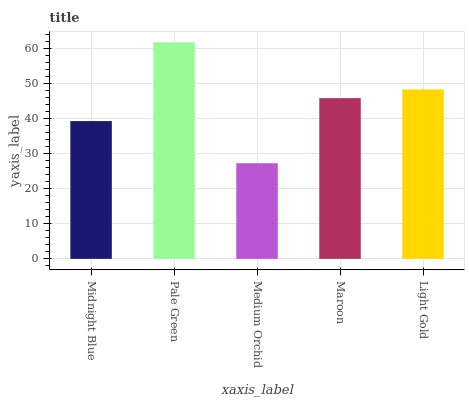Is Medium Orchid the minimum?
Answer yes or no. Yes. Is Pale Green the maximum?
Answer yes or no. Yes. Is Pale Green the minimum?
Answer yes or no. No. Is Medium Orchid the maximum?
Answer yes or no. No. Is Pale Green greater than Medium Orchid?
Answer yes or no. Yes. Is Medium Orchid less than Pale Green?
Answer yes or no. Yes. Is Medium Orchid greater than Pale Green?
Answer yes or no. No. Is Pale Green less than Medium Orchid?
Answer yes or no. No. Is Maroon the high median?
Answer yes or no. Yes. Is Maroon the low median?
Answer yes or no. Yes. Is Midnight Blue the high median?
Answer yes or no. No. Is Medium Orchid the low median?
Answer yes or no. No. 